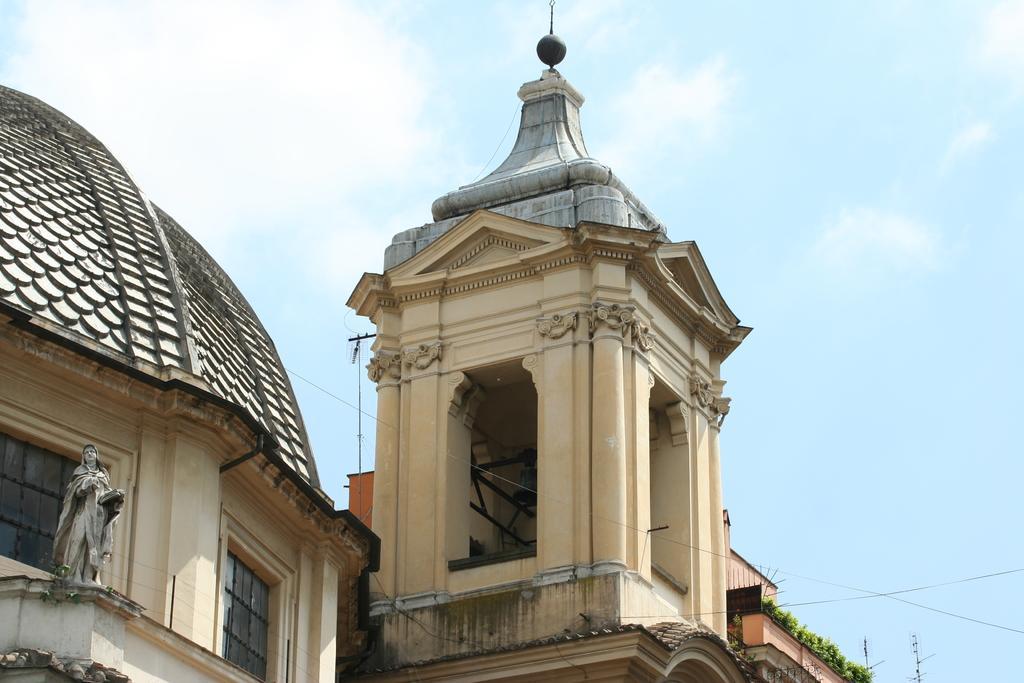Could you give a brief overview of what you see in this image? These are the buildings with pillars and windows. I can see a sculpture, which is placed on the building. These are the small plants. This looks like a spire at the top of the building. I think this is a pole. 